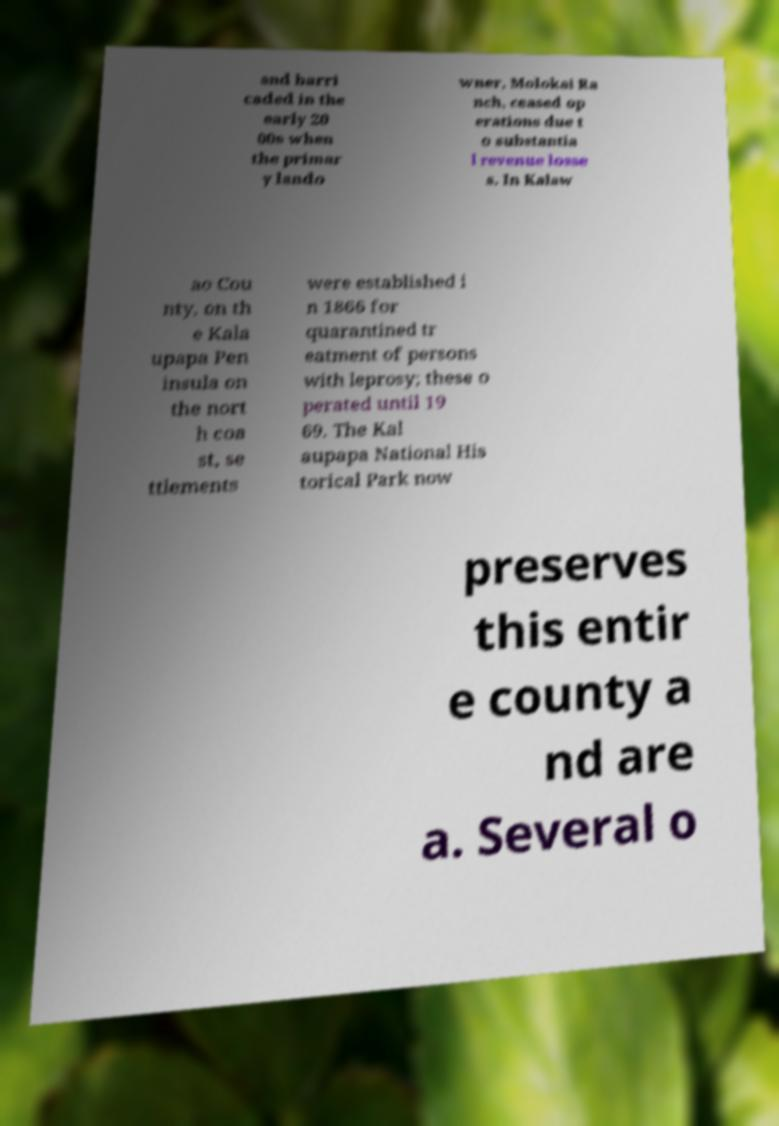There's text embedded in this image that I need extracted. Can you transcribe it verbatim? and barri caded in the early 20 00s when the primar y lando wner, Molokai Ra nch, ceased op erations due t o substantia l revenue losse s. In Kalaw ao Cou nty, on th e Kala upapa Pen insula on the nort h coa st, se ttlements were established i n 1866 for quarantined tr eatment of persons with leprosy; these o perated until 19 69. The Kal aupapa National His torical Park now preserves this entir e county a nd are a. Several o 